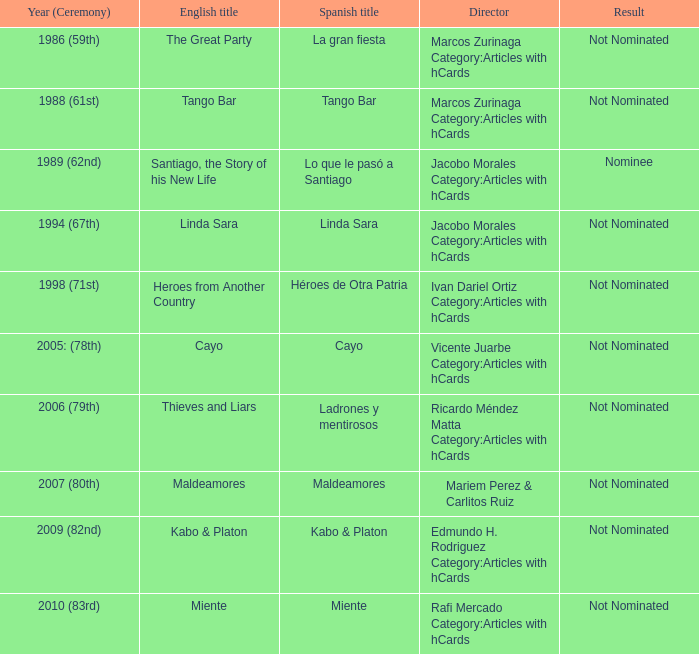Would you be able to parse every entry in this table? {'header': ['Year (Ceremony)', 'English title', 'Spanish title', 'Director', 'Result'], 'rows': [['1986 (59th)', 'The Great Party', 'La gran fiesta', 'Marcos Zurinaga Category:Articles with hCards', 'Not Nominated'], ['1988 (61st)', 'Tango Bar', 'Tango Bar', 'Marcos Zurinaga Category:Articles with hCards', 'Not Nominated'], ['1989 (62nd)', 'Santiago, the Story of his New Life', 'Lo que le pasó a Santiago', 'Jacobo Morales Category:Articles with hCards', 'Nominee'], ['1994 (67th)', 'Linda Sara', 'Linda Sara', 'Jacobo Morales Category:Articles with hCards', 'Not Nominated'], ['1998 (71st)', 'Heroes from Another Country', 'Héroes de Otra Patria', 'Ivan Dariel Ortiz Category:Articles with hCards', 'Not Nominated'], ['2005: (78th)', 'Cayo', 'Cayo', 'Vicente Juarbe Category:Articles with hCards', 'Not Nominated'], ['2006 (79th)', 'Thieves and Liars', 'Ladrones y mentirosos', 'Ricardo Méndez Matta Category:Articles with hCards', 'Not Nominated'], ['2007 (80th)', 'Maldeamores', 'Maldeamores', 'Mariem Perez & Carlitos Ruiz', 'Not Nominated'], ['2009 (82nd)', 'Kabo & Platon', 'Kabo & Platon', 'Edmundo H. Rodriguez Category:Articles with hCards', 'Not Nominated'], ['2010 (83rd)', 'Miente', 'Miente', 'Rafi Mercado Category:Articles with hCards', 'Not Nominated']]} What was the english designation for the movie that was a contender? Santiago, the Story of his New Life. 